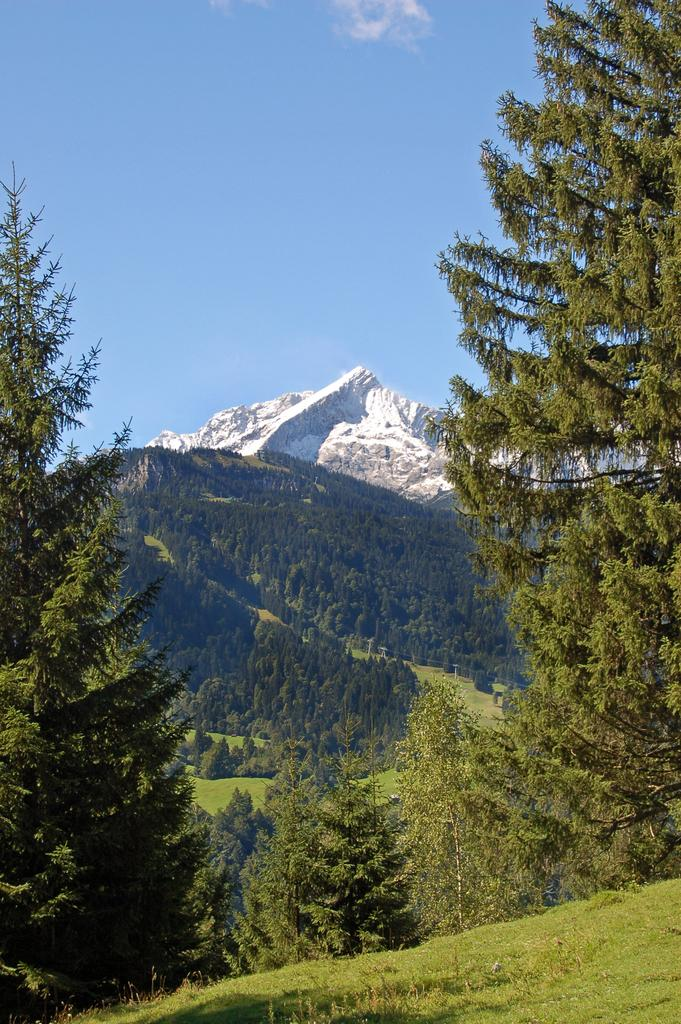What type of vegetation can be seen in the image? There is a group of trees and grass in the image. Can you describe the landscape in the background of the image? There is a group of trees on a hill in the background, and the hill appears to be covered in ice. What is visible in the sky in the image? The sky is visible and appears cloudy. What type of bubble can be seen floating in the image? There is no bubble present in the image. Is there a ring visible on any of the trees in the image? There is no ring visible on any of the trees in the image. 